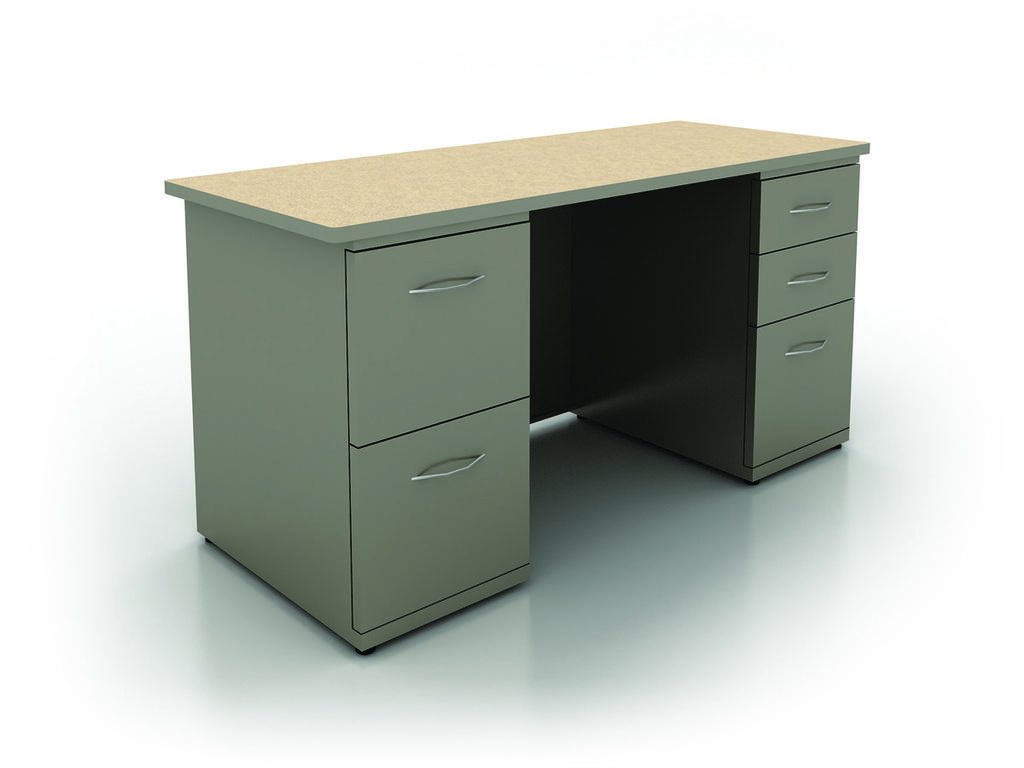In one or two sentences, can you explain what this image depicts? In this picture I can see a table in front, which is on the white color surface and I can see the white color background. 